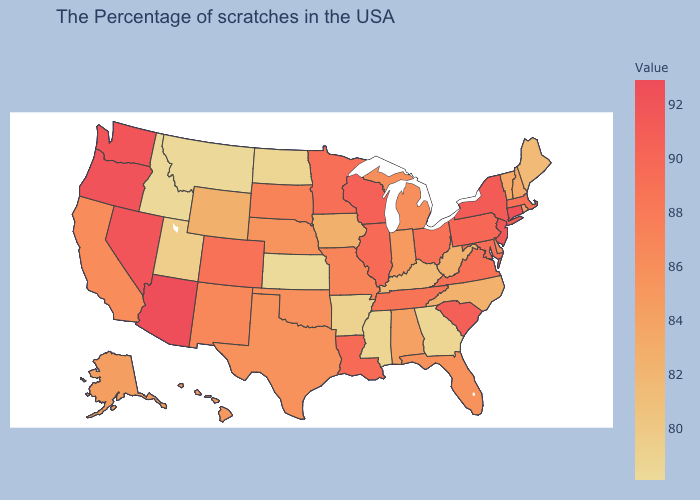Does Michigan have a higher value than Oregon?
Concise answer only. No. Does the map have missing data?
Quick response, please. No. Among the states that border South Carolina , does North Carolina have the highest value?
Short answer required. Yes. Among the states that border Nevada , which have the lowest value?
Short answer required. Idaho. Among the states that border Kansas , does Nebraska have the lowest value?
Keep it brief. Yes. Which states have the lowest value in the USA?
Short answer required. Kansas. 